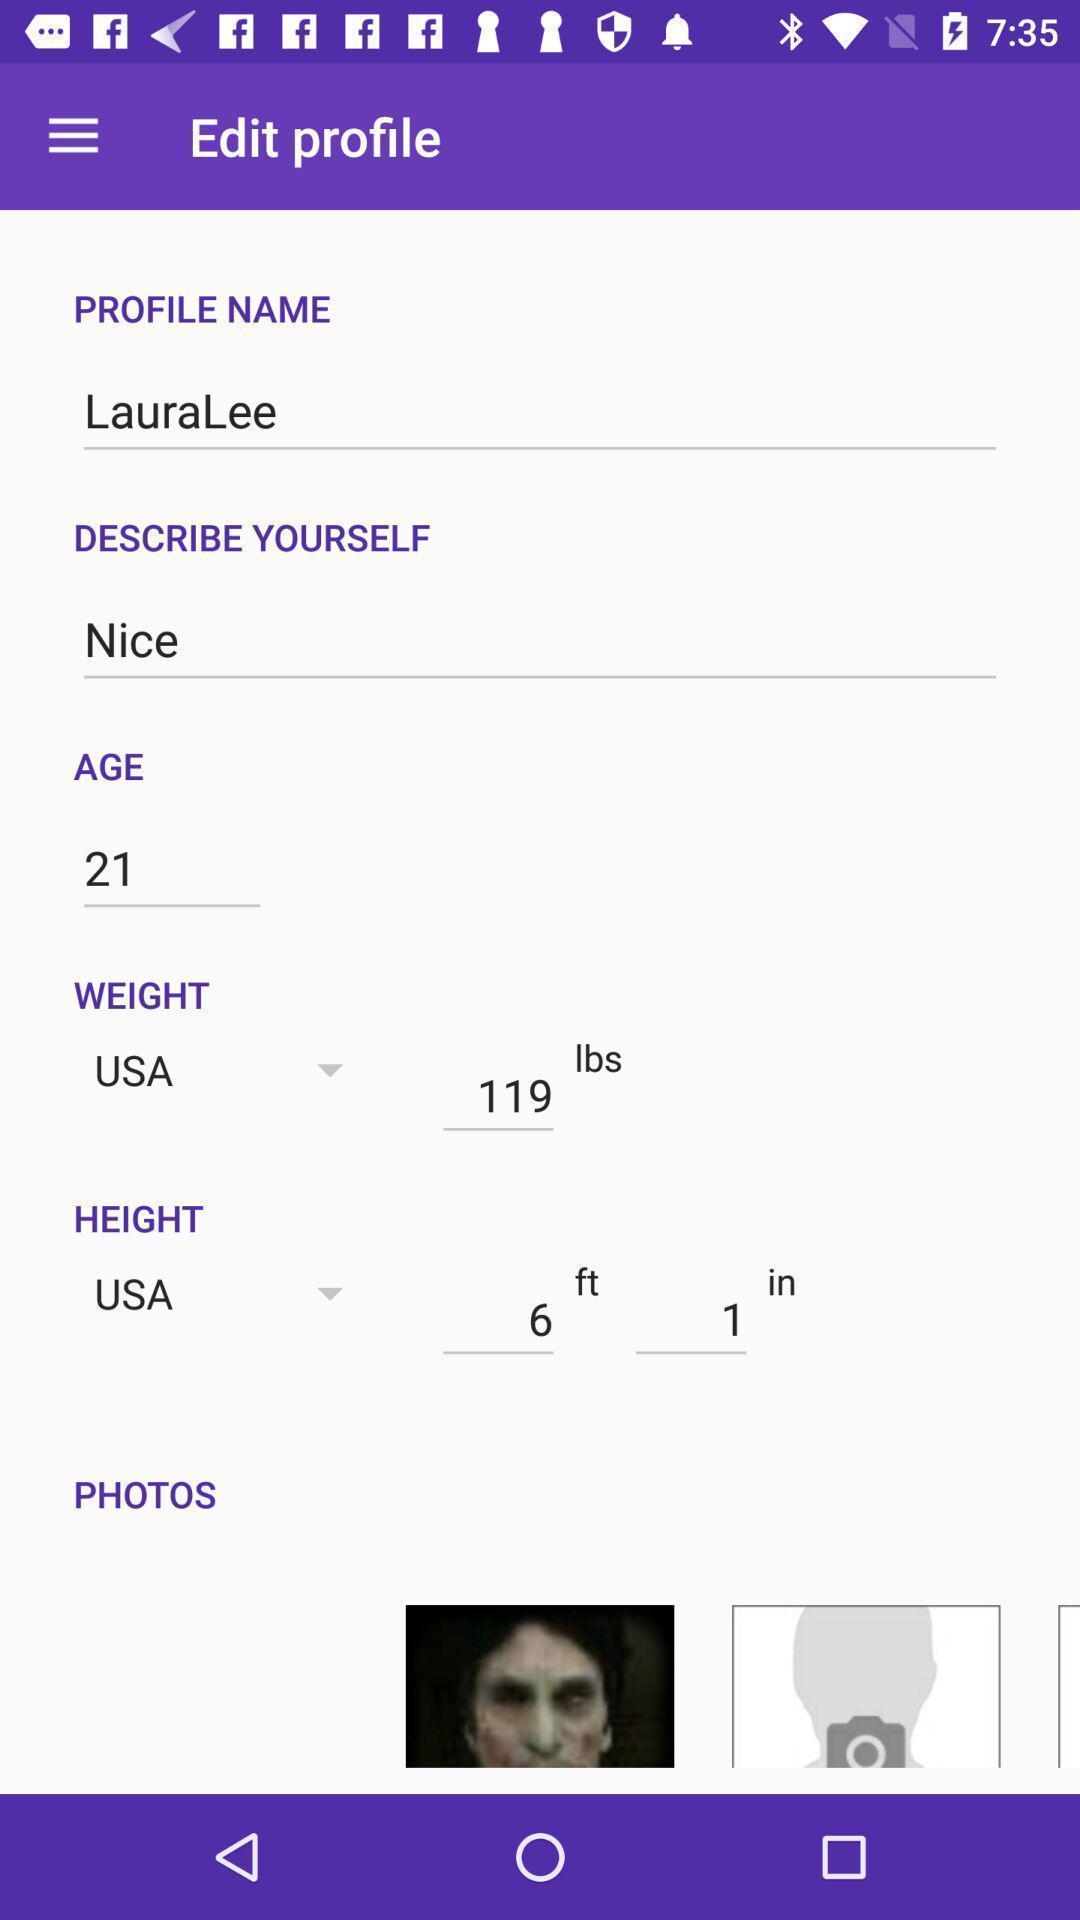Tell me what you see in this picture. Screen showing edit profile page. 